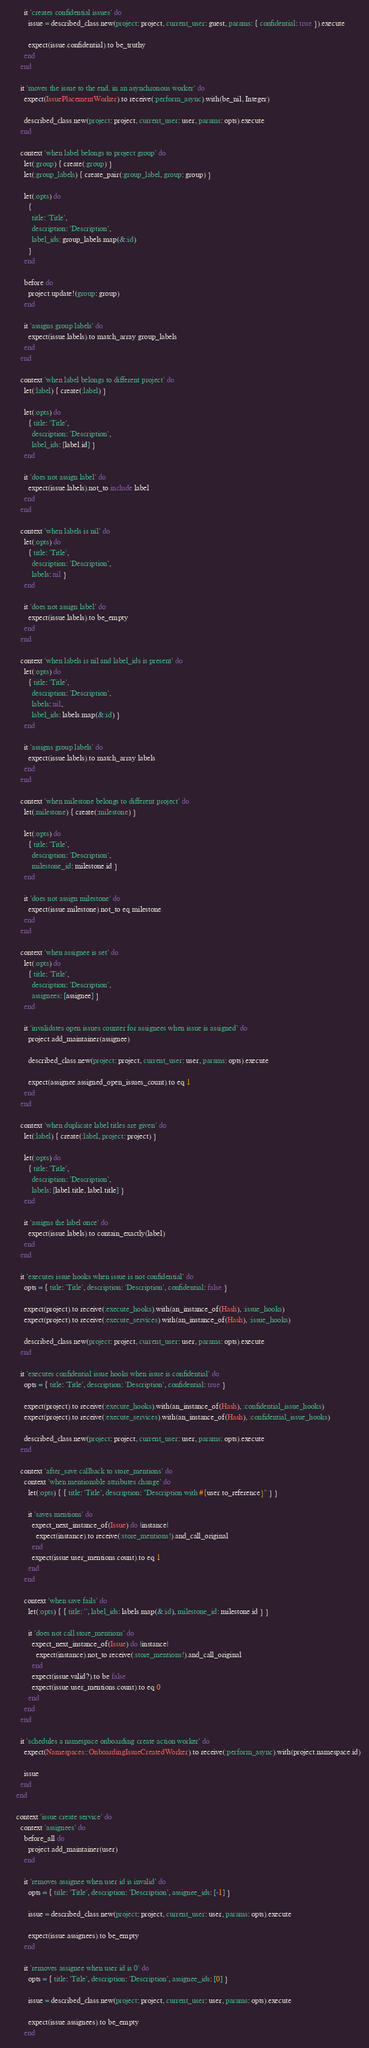<code> <loc_0><loc_0><loc_500><loc_500><_Ruby_>
        it 'creates confidential issues' do
          issue = described_class.new(project: project, current_user: guest, params: { confidential: true }).execute

          expect(issue.confidential).to be_truthy
        end
      end

      it 'moves the issue to the end, in an asynchronous worker' do
        expect(IssuePlacementWorker).to receive(:perform_async).with(be_nil, Integer)

        described_class.new(project: project, current_user: user, params: opts).execute
      end

      context 'when label belongs to project group' do
        let(:group) { create(:group) }
        let(:group_labels) { create_pair(:group_label, group: group) }

        let(:opts) do
          {
            title: 'Title',
            description: 'Description',
            label_ids: group_labels.map(&:id)
          }
        end

        before do
          project.update!(group: group)
        end

        it 'assigns group labels' do
          expect(issue.labels).to match_array group_labels
        end
      end

      context 'when label belongs to different project' do
        let(:label) { create(:label) }

        let(:opts) do
          { title: 'Title',
            description: 'Description',
            label_ids: [label.id] }
        end

        it 'does not assign label' do
          expect(issue.labels).not_to include label
        end
      end

      context 'when labels is nil' do
        let(:opts) do
          { title: 'Title',
            description: 'Description',
            labels: nil }
        end

        it 'does not assign label' do
          expect(issue.labels).to be_empty
        end
      end

      context 'when labels is nil and label_ids is present' do
        let(:opts) do
          { title: 'Title',
            description: 'Description',
            labels: nil,
            label_ids: labels.map(&:id) }
        end

        it 'assigns group labels' do
          expect(issue.labels).to match_array labels
        end
      end

      context 'when milestone belongs to different project' do
        let(:milestone) { create(:milestone) }

        let(:opts) do
          { title: 'Title',
            description: 'Description',
            milestone_id: milestone.id }
        end

        it 'does not assign milestone' do
          expect(issue.milestone).not_to eq milestone
        end
      end

      context 'when assignee is set' do
        let(:opts) do
          { title: 'Title',
            description: 'Description',
            assignees: [assignee] }
        end

        it 'invalidates open issues counter for assignees when issue is assigned' do
          project.add_maintainer(assignee)

          described_class.new(project: project, current_user: user, params: opts).execute

          expect(assignee.assigned_open_issues_count).to eq 1
        end
      end

      context 'when duplicate label titles are given' do
        let(:label) { create(:label, project: project) }

        let(:opts) do
          { title: 'Title',
            description: 'Description',
            labels: [label.title, label.title] }
        end

        it 'assigns the label once' do
          expect(issue.labels).to contain_exactly(label)
        end
      end

      it 'executes issue hooks when issue is not confidential' do
        opts = { title: 'Title', description: 'Description', confidential: false }

        expect(project).to receive(:execute_hooks).with(an_instance_of(Hash), :issue_hooks)
        expect(project).to receive(:execute_services).with(an_instance_of(Hash), :issue_hooks)

        described_class.new(project: project, current_user: user, params: opts).execute
      end

      it 'executes confidential issue hooks when issue is confidential' do
        opts = { title: 'Title', description: 'Description', confidential: true }

        expect(project).to receive(:execute_hooks).with(an_instance_of(Hash), :confidential_issue_hooks)
        expect(project).to receive(:execute_services).with(an_instance_of(Hash), :confidential_issue_hooks)

        described_class.new(project: project, current_user: user, params: opts).execute
      end

      context 'after_save callback to store_mentions' do
        context 'when mentionable attributes change' do
          let(:opts) { { title: 'Title', description: "Description with #{user.to_reference}" } }

          it 'saves mentions' do
            expect_next_instance_of(Issue) do |instance|
              expect(instance).to receive(:store_mentions!).and_call_original
            end
            expect(issue.user_mentions.count).to eq 1
          end
        end

        context 'when save fails' do
          let(:opts) { { title: '', label_ids: labels.map(&:id), milestone_id: milestone.id } }

          it 'does not call store_mentions' do
            expect_next_instance_of(Issue) do |instance|
              expect(instance).not_to receive(:store_mentions!).and_call_original
            end
            expect(issue.valid?).to be false
            expect(issue.user_mentions.count).to eq 0
          end
        end
      end

      it 'schedules a namespace onboarding create action worker' do
        expect(Namespaces::OnboardingIssueCreatedWorker).to receive(:perform_async).with(project.namespace.id)

        issue
      end
    end

    context 'issue create service' do
      context 'assignees' do
        before_all do
          project.add_maintainer(user)
        end

        it 'removes assignee when user id is invalid' do
          opts = { title: 'Title', description: 'Description', assignee_ids: [-1] }

          issue = described_class.new(project: project, current_user: user, params: opts).execute

          expect(issue.assignees).to be_empty
        end

        it 'removes assignee when user id is 0' do
          opts = { title: 'Title', description: 'Description', assignee_ids: [0] }

          issue = described_class.new(project: project, current_user: user, params: opts).execute

          expect(issue.assignees).to be_empty
        end
</code> 